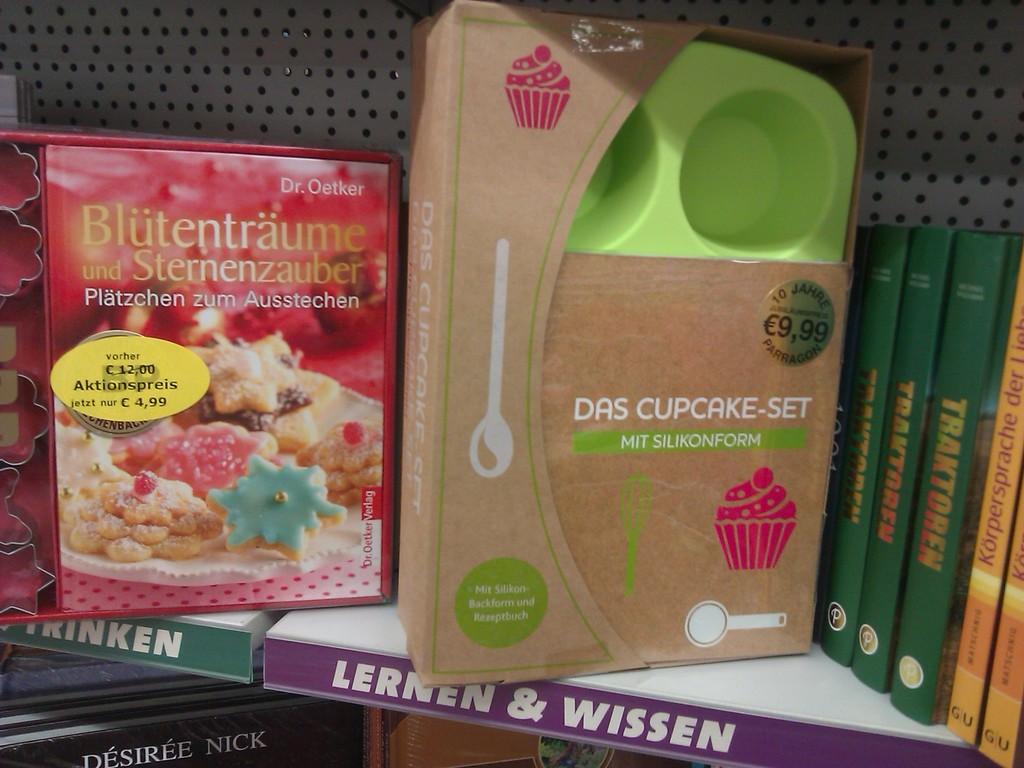What can you make with the set?
Your answer should be compact. Cupcake. What is the price of the cupcake set?
Your response must be concise. 9.99. 